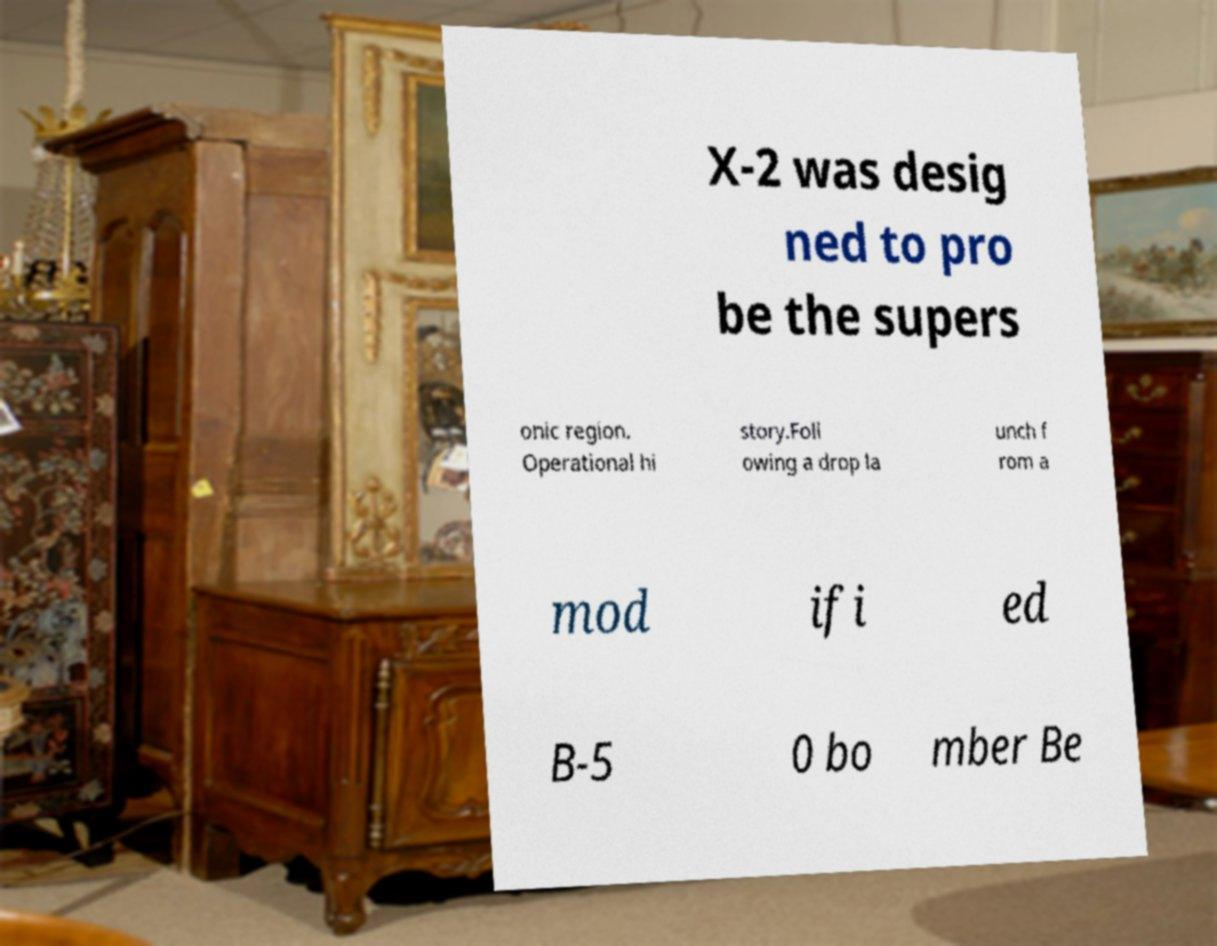There's text embedded in this image that I need extracted. Can you transcribe it verbatim? X-2 was desig ned to pro be the supers onic region. Operational hi story.Foll owing a drop la unch f rom a mod ifi ed B-5 0 bo mber Be 